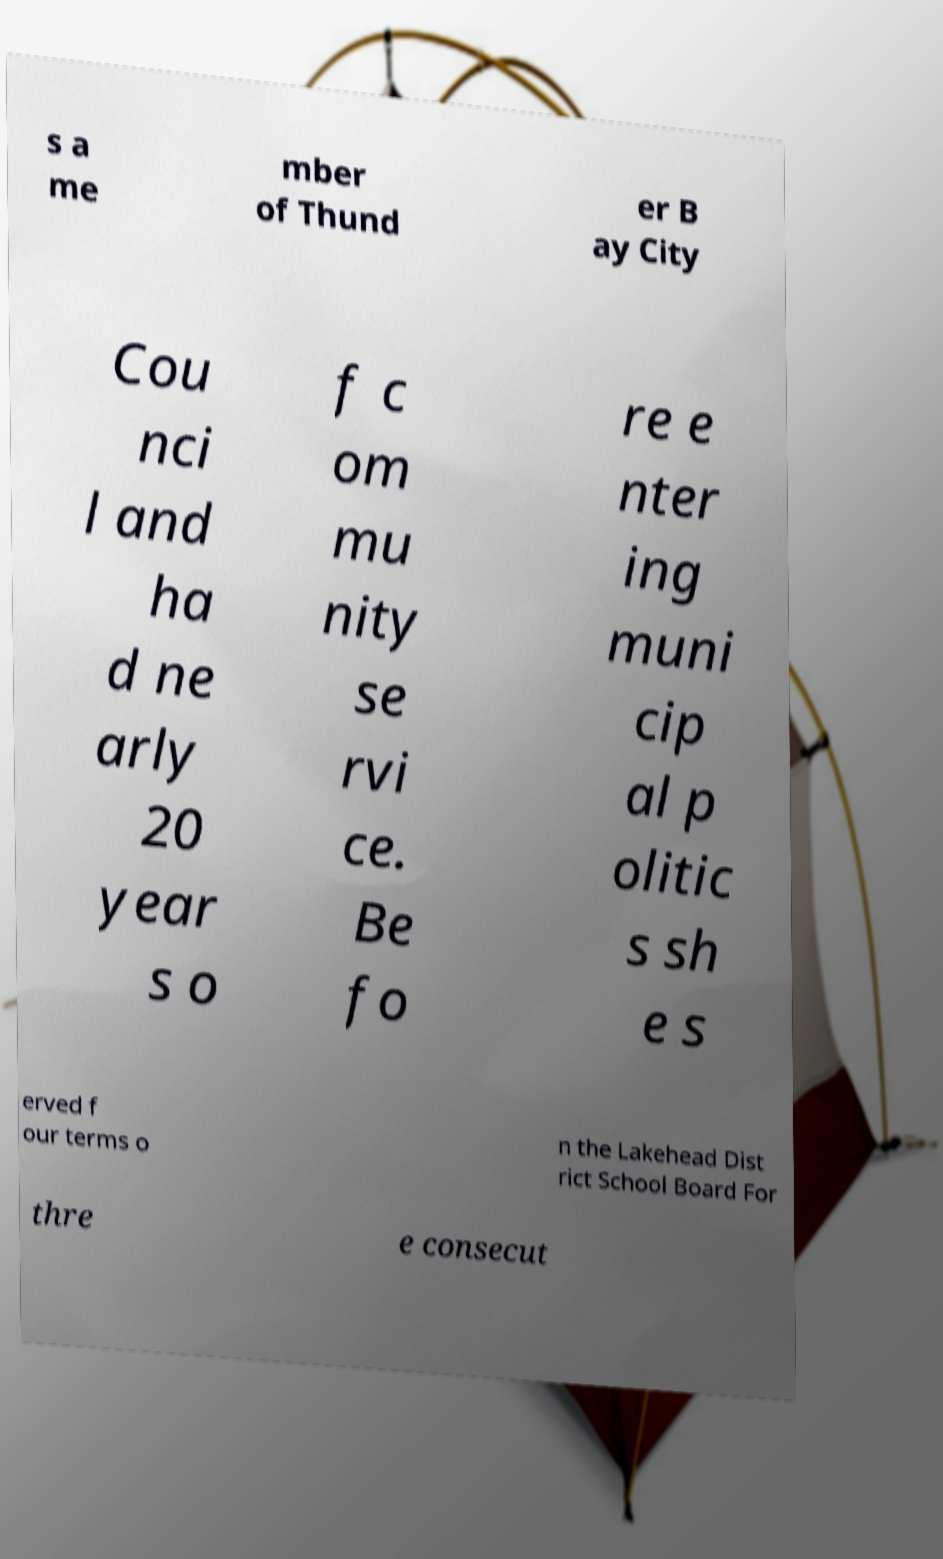I need the written content from this picture converted into text. Can you do that? s a me mber of Thund er B ay City Cou nci l and ha d ne arly 20 year s o f c om mu nity se rvi ce. Be fo re e nter ing muni cip al p olitic s sh e s erved f our terms o n the Lakehead Dist rict School Board For thre e consecut 